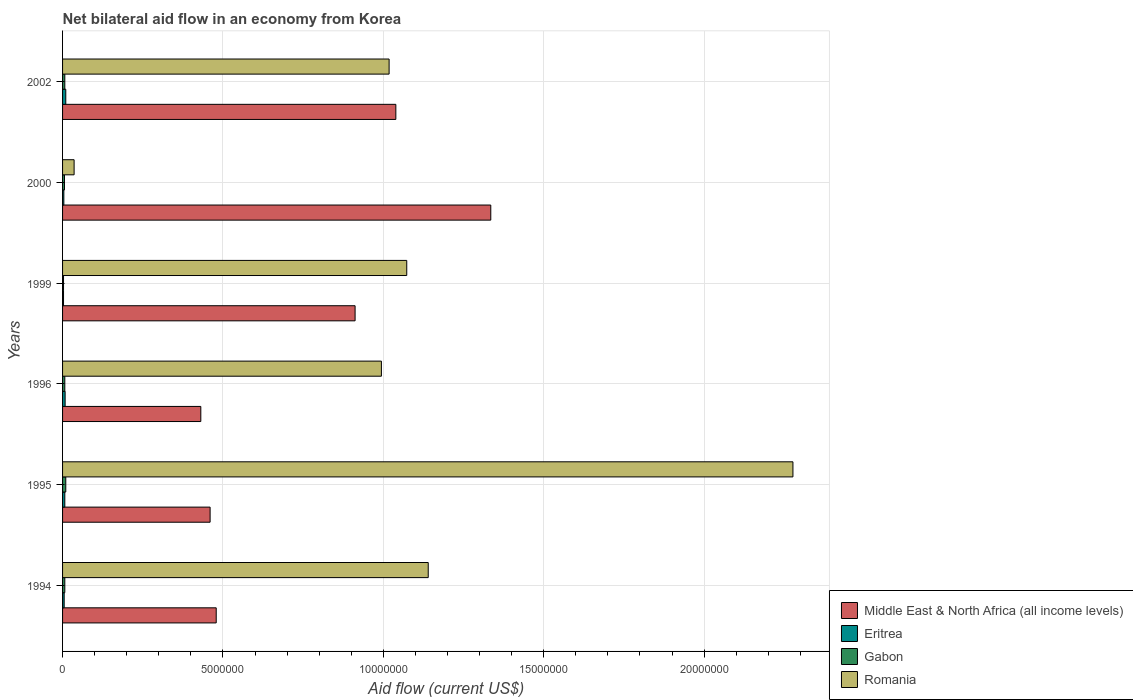Are the number of bars per tick equal to the number of legend labels?
Keep it short and to the point. Yes. Are the number of bars on each tick of the Y-axis equal?
Your answer should be compact. Yes. What is the label of the 4th group of bars from the top?
Your answer should be very brief. 1996. In how many cases, is the number of bars for a given year not equal to the number of legend labels?
Offer a terse response. 0. What is the net bilateral aid flow in Middle East & North Africa (all income levels) in 2000?
Offer a terse response. 1.34e+07. Across all years, what is the maximum net bilateral aid flow in Eritrea?
Give a very brief answer. 1.00e+05. In which year was the net bilateral aid flow in Romania maximum?
Offer a terse response. 1995. What is the total net bilateral aid flow in Eritrea in the graph?
Offer a terse response. 3.70e+05. What is the difference between the net bilateral aid flow in Romania in 1999 and that in 2000?
Ensure brevity in your answer.  1.04e+07. What is the difference between the net bilateral aid flow in Romania in 2000 and the net bilateral aid flow in Middle East & North Africa (all income levels) in 1999?
Keep it short and to the point. -8.76e+06. What is the average net bilateral aid flow in Middle East & North Africa (all income levels) per year?
Make the answer very short. 7.76e+06. In the year 1994, what is the difference between the net bilateral aid flow in Middle East & North Africa (all income levels) and net bilateral aid flow in Gabon?
Make the answer very short. 4.72e+06. What is the ratio of the net bilateral aid flow in Middle East & North Africa (all income levels) in 1994 to that in 1996?
Offer a terse response. 1.11. What is the difference between the highest and the lowest net bilateral aid flow in Gabon?
Keep it short and to the point. 7.00e+04. In how many years, is the net bilateral aid flow in Romania greater than the average net bilateral aid flow in Romania taken over all years?
Make the answer very short. 2. Is it the case that in every year, the sum of the net bilateral aid flow in Romania and net bilateral aid flow in Gabon is greater than the sum of net bilateral aid flow in Middle East & North Africa (all income levels) and net bilateral aid flow in Eritrea?
Provide a succinct answer. Yes. What does the 1st bar from the top in 1999 represents?
Ensure brevity in your answer.  Romania. What does the 3rd bar from the bottom in 1994 represents?
Provide a short and direct response. Gabon. Is it the case that in every year, the sum of the net bilateral aid flow in Eritrea and net bilateral aid flow in Romania is greater than the net bilateral aid flow in Gabon?
Provide a short and direct response. Yes. Are all the bars in the graph horizontal?
Your response must be concise. Yes. How many legend labels are there?
Provide a short and direct response. 4. How are the legend labels stacked?
Make the answer very short. Vertical. What is the title of the graph?
Your answer should be compact. Net bilateral aid flow in an economy from Korea. What is the label or title of the Y-axis?
Give a very brief answer. Years. What is the Aid flow (current US$) in Middle East & North Africa (all income levels) in 1994?
Ensure brevity in your answer.  4.79e+06. What is the Aid flow (current US$) in Eritrea in 1994?
Provide a short and direct response. 5.00e+04. What is the Aid flow (current US$) in Romania in 1994?
Offer a terse response. 1.14e+07. What is the Aid flow (current US$) of Middle East & North Africa (all income levels) in 1995?
Give a very brief answer. 4.60e+06. What is the Aid flow (current US$) in Eritrea in 1995?
Your answer should be very brief. 7.00e+04. What is the Aid flow (current US$) of Romania in 1995?
Your response must be concise. 2.28e+07. What is the Aid flow (current US$) in Middle East & North Africa (all income levels) in 1996?
Give a very brief answer. 4.31e+06. What is the Aid flow (current US$) in Eritrea in 1996?
Provide a succinct answer. 8.00e+04. What is the Aid flow (current US$) in Romania in 1996?
Make the answer very short. 9.94e+06. What is the Aid flow (current US$) of Middle East & North Africa (all income levels) in 1999?
Offer a very short reply. 9.12e+06. What is the Aid flow (current US$) of Eritrea in 1999?
Your answer should be very brief. 3.00e+04. What is the Aid flow (current US$) of Romania in 1999?
Make the answer very short. 1.07e+07. What is the Aid flow (current US$) of Middle East & North Africa (all income levels) in 2000?
Keep it short and to the point. 1.34e+07. What is the Aid flow (current US$) in Romania in 2000?
Make the answer very short. 3.60e+05. What is the Aid flow (current US$) in Middle East & North Africa (all income levels) in 2002?
Your response must be concise. 1.04e+07. What is the Aid flow (current US$) of Romania in 2002?
Your answer should be compact. 1.02e+07. Across all years, what is the maximum Aid flow (current US$) in Middle East & North Africa (all income levels)?
Give a very brief answer. 1.34e+07. Across all years, what is the maximum Aid flow (current US$) of Gabon?
Your answer should be very brief. 1.00e+05. Across all years, what is the maximum Aid flow (current US$) of Romania?
Make the answer very short. 2.28e+07. Across all years, what is the minimum Aid flow (current US$) in Middle East & North Africa (all income levels)?
Ensure brevity in your answer.  4.31e+06. Across all years, what is the minimum Aid flow (current US$) in Gabon?
Your answer should be compact. 3.00e+04. What is the total Aid flow (current US$) of Middle East & North Africa (all income levels) in the graph?
Your answer should be compact. 4.66e+07. What is the total Aid flow (current US$) in Gabon in the graph?
Keep it short and to the point. 4.00e+05. What is the total Aid flow (current US$) of Romania in the graph?
Make the answer very short. 6.54e+07. What is the difference between the Aid flow (current US$) in Eritrea in 1994 and that in 1995?
Your answer should be very brief. -2.00e+04. What is the difference between the Aid flow (current US$) in Romania in 1994 and that in 1995?
Offer a very short reply. -1.14e+07. What is the difference between the Aid flow (current US$) of Eritrea in 1994 and that in 1996?
Ensure brevity in your answer.  -3.00e+04. What is the difference between the Aid flow (current US$) of Romania in 1994 and that in 1996?
Offer a very short reply. 1.46e+06. What is the difference between the Aid flow (current US$) in Middle East & North Africa (all income levels) in 1994 and that in 1999?
Give a very brief answer. -4.33e+06. What is the difference between the Aid flow (current US$) of Eritrea in 1994 and that in 1999?
Offer a very short reply. 2.00e+04. What is the difference between the Aid flow (current US$) in Gabon in 1994 and that in 1999?
Your answer should be compact. 4.00e+04. What is the difference between the Aid flow (current US$) in Romania in 1994 and that in 1999?
Give a very brief answer. 6.70e+05. What is the difference between the Aid flow (current US$) in Middle East & North Africa (all income levels) in 1994 and that in 2000?
Provide a succinct answer. -8.56e+06. What is the difference between the Aid flow (current US$) in Eritrea in 1994 and that in 2000?
Ensure brevity in your answer.  10000. What is the difference between the Aid flow (current US$) in Romania in 1994 and that in 2000?
Give a very brief answer. 1.10e+07. What is the difference between the Aid flow (current US$) in Middle East & North Africa (all income levels) in 1994 and that in 2002?
Provide a succinct answer. -5.60e+06. What is the difference between the Aid flow (current US$) in Eritrea in 1994 and that in 2002?
Ensure brevity in your answer.  -5.00e+04. What is the difference between the Aid flow (current US$) of Romania in 1994 and that in 2002?
Make the answer very short. 1.22e+06. What is the difference between the Aid flow (current US$) in Middle East & North Africa (all income levels) in 1995 and that in 1996?
Provide a succinct answer. 2.90e+05. What is the difference between the Aid flow (current US$) of Gabon in 1995 and that in 1996?
Offer a very short reply. 3.00e+04. What is the difference between the Aid flow (current US$) of Romania in 1995 and that in 1996?
Give a very brief answer. 1.28e+07. What is the difference between the Aid flow (current US$) of Middle East & North Africa (all income levels) in 1995 and that in 1999?
Give a very brief answer. -4.52e+06. What is the difference between the Aid flow (current US$) in Eritrea in 1995 and that in 1999?
Provide a succinct answer. 4.00e+04. What is the difference between the Aid flow (current US$) in Romania in 1995 and that in 1999?
Provide a short and direct response. 1.20e+07. What is the difference between the Aid flow (current US$) of Middle East & North Africa (all income levels) in 1995 and that in 2000?
Your answer should be very brief. -8.75e+06. What is the difference between the Aid flow (current US$) in Eritrea in 1995 and that in 2000?
Provide a succinct answer. 3.00e+04. What is the difference between the Aid flow (current US$) in Romania in 1995 and that in 2000?
Your response must be concise. 2.24e+07. What is the difference between the Aid flow (current US$) of Middle East & North Africa (all income levels) in 1995 and that in 2002?
Provide a succinct answer. -5.79e+06. What is the difference between the Aid flow (current US$) in Eritrea in 1995 and that in 2002?
Provide a short and direct response. -3.00e+04. What is the difference between the Aid flow (current US$) of Romania in 1995 and that in 2002?
Your response must be concise. 1.26e+07. What is the difference between the Aid flow (current US$) in Middle East & North Africa (all income levels) in 1996 and that in 1999?
Your response must be concise. -4.81e+06. What is the difference between the Aid flow (current US$) of Eritrea in 1996 and that in 1999?
Keep it short and to the point. 5.00e+04. What is the difference between the Aid flow (current US$) of Gabon in 1996 and that in 1999?
Make the answer very short. 4.00e+04. What is the difference between the Aid flow (current US$) of Romania in 1996 and that in 1999?
Ensure brevity in your answer.  -7.90e+05. What is the difference between the Aid flow (current US$) in Middle East & North Africa (all income levels) in 1996 and that in 2000?
Provide a short and direct response. -9.04e+06. What is the difference between the Aid flow (current US$) in Eritrea in 1996 and that in 2000?
Ensure brevity in your answer.  4.00e+04. What is the difference between the Aid flow (current US$) in Romania in 1996 and that in 2000?
Make the answer very short. 9.58e+06. What is the difference between the Aid flow (current US$) of Middle East & North Africa (all income levels) in 1996 and that in 2002?
Give a very brief answer. -6.08e+06. What is the difference between the Aid flow (current US$) of Eritrea in 1996 and that in 2002?
Your answer should be compact. -2.00e+04. What is the difference between the Aid flow (current US$) in Middle East & North Africa (all income levels) in 1999 and that in 2000?
Provide a short and direct response. -4.23e+06. What is the difference between the Aid flow (current US$) in Eritrea in 1999 and that in 2000?
Your response must be concise. -10000. What is the difference between the Aid flow (current US$) in Gabon in 1999 and that in 2000?
Offer a terse response. -3.00e+04. What is the difference between the Aid flow (current US$) in Romania in 1999 and that in 2000?
Offer a terse response. 1.04e+07. What is the difference between the Aid flow (current US$) in Middle East & North Africa (all income levels) in 1999 and that in 2002?
Give a very brief answer. -1.27e+06. What is the difference between the Aid flow (current US$) in Gabon in 1999 and that in 2002?
Provide a succinct answer. -4.00e+04. What is the difference between the Aid flow (current US$) in Romania in 1999 and that in 2002?
Your answer should be very brief. 5.50e+05. What is the difference between the Aid flow (current US$) of Middle East & North Africa (all income levels) in 2000 and that in 2002?
Offer a terse response. 2.96e+06. What is the difference between the Aid flow (current US$) in Eritrea in 2000 and that in 2002?
Keep it short and to the point. -6.00e+04. What is the difference between the Aid flow (current US$) in Romania in 2000 and that in 2002?
Keep it short and to the point. -9.82e+06. What is the difference between the Aid flow (current US$) of Middle East & North Africa (all income levels) in 1994 and the Aid flow (current US$) of Eritrea in 1995?
Provide a short and direct response. 4.72e+06. What is the difference between the Aid flow (current US$) in Middle East & North Africa (all income levels) in 1994 and the Aid flow (current US$) in Gabon in 1995?
Your answer should be compact. 4.69e+06. What is the difference between the Aid flow (current US$) of Middle East & North Africa (all income levels) in 1994 and the Aid flow (current US$) of Romania in 1995?
Offer a very short reply. -1.80e+07. What is the difference between the Aid flow (current US$) of Eritrea in 1994 and the Aid flow (current US$) of Gabon in 1995?
Give a very brief answer. -5.00e+04. What is the difference between the Aid flow (current US$) in Eritrea in 1994 and the Aid flow (current US$) in Romania in 1995?
Your response must be concise. -2.27e+07. What is the difference between the Aid flow (current US$) in Gabon in 1994 and the Aid flow (current US$) in Romania in 1995?
Keep it short and to the point. -2.27e+07. What is the difference between the Aid flow (current US$) in Middle East & North Africa (all income levels) in 1994 and the Aid flow (current US$) in Eritrea in 1996?
Give a very brief answer. 4.71e+06. What is the difference between the Aid flow (current US$) in Middle East & North Africa (all income levels) in 1994 and the Aid flow (current US$) in Gabon in 1996?
Provide a short and direct response. 4.72e+06. What is the difference between the Aid flow (current US$) in Middle East & North Africa (all income levels) in 1994 and the Aid flow (current US$) in Romania in 1996?
Ensure brevity in your answer.  -5.15e+06. What is the difference between the Aid flow (current US$) in Eritrea in 1994 and the Aid flow (current US$) in Gabon in 1996?
Your answer should be compact. -2.00e+04. What is the difference between the Aid flow (current US$) in Eritrea in 1994 and the Aid flow (current US$) in Romania in 1996?
Provide a short and direct response. -9.89e+06. What is the difference between the Aid flow (current US$) in Gabon in 1994 and the Aid flow (current US$) in Romania in 1996?
Offer a terse response. -9.87e+06. What is the difference between the Aid flow (current US$) of Middle East & North Africa (all income levels) in 1994 and the Aid flow (current US$) of Eritrea in 1999?
Provide a succinct answer. 4.76e+06. What is the difference between the Aid flow (current US$) in Middle East & North Africa (all income levels) in 1994 and the Aid flow (current US$) in Gabon in 1999?
Offer a very short reply. 4.76e+06. What is the difference between the Aid flow (current US$) of Middle East & North Africa (all income levels) in 1994 and the Aid flow (current US$) of Romania in 1999?
Provide a succinct answer. -5.94e+06. What is the difference between the Aid flow (current US$) in Eritrea in 1994 and the Aid flow (current US$) in Gabon in 1999?
Offer a terse response. 2.00e+04. What is the difference between the Aid flow (current US$) of Eritrea in 1994 and the Aid flow (current US$) of Romania in 1999?
Your response must be concise. -1.07e+07. What is the difference between the Aid flow (current US$) of Gabon in 1994 and the Aid flow (current US$) of Romania in 1999?
Give a very brief answer. -1.07e+07. What is the difference between the Aid flow (current US$) in Middle East & North Africa (all income levels) in 1994 and the Aid flow (current US$) in Eritrea in 2000?
Provide a short and direct response. 4.75e+06. What is the difference between the Aid flow (current US$) in Middle East & North Africa (all income levels) in 1994 and the Aid flow (current US$) in Gabon in 2000?
Offer a terse response. 4.73e+06. What is the difference between the Aid flow (current US$) of Middle East & North Africa (all income levels) in 1994 and the Aid flow (current US$) of Romania in 2000?
Your answer should be compact. 4.43e+06. What is the difference between the Aid flow (current US$) in Eritrea in 1994 and the Aid flow (current US$) in Romania in 2000?
Make the answer very short. -3.10e+05. What is the difference between the Aid flow (current US$) in Gabon in 1994 and the Aid flow (current US$) in Romania in 2000?
Give a very brief answer. -2.90e+05. What is the difference between the Aid flow (current US$) of Middle East & North Africa (all income levels) in 1994 and the Aid flow (current US$) of Eritrea in 2002?
Provide a succinct answer. 4.69e+06. What is the difference between the Aid flow (current US$) in Middle East & North Africa (all income levels) in 1994 and the Aid flow (current US$) in Gabon in 2002?
Make the answer very short. 4.72e+06. What is the difference between the Aid flow (current US$) of Middle East & North Africa (all income levels) in 1994 and the Aid flow (current US$) of Romania in 2002?
Your answer should be compact. -5.39e+06. What is the difference between the Aid flow (current US$) of Eritrea in 1994 and the Aid flow (current US$) of Romania in 2002?
Make the answer very short. -1.01e+07. What is the difference between the Aid flow (current US$) of Gabon in 1994 and the Aid flow (current US$) of Romania in 2002?
Offer a terse response. -1.01e+07. What is the difference between the Aid flow (current US$) in Middle East & North Africa (all income levels) in 1995 and the Aid flow (current US$) in Eritrea in 1996?
Provide a short and direct response. 4.52e+06. What is the difference between the Aid flow (current US$) in Middle East & North Africa (all income levels) in 1995 and the Aid flow (current US$) in Gabon in 1996?
Offer a terse response. 4.53e+06. What is the difference between the Aid flow (current US$) of Middle East & North Africa (all income levels) in 1995 and the Aid flow (current US$) of Romania in 1996?
Offer a terse response. -5.34e+06. What is the difference between the Aid flow (current US$) of Eritrea in 1995 and the Aid flow (current US$) of Romania in 1996?
Provide a short and direct response. -9.87e+06. What is the difference between the Aid flow (current US$) of Gabon in 1995 and the Aid flow (current US$) of Romania in 1996?
Offer a terse response. -9.84e+06. What is the difference between the Aid flow (current US$) in Middle East & North Africa (all income levels) in 1995 and the Aid flow (current US$) in Eritrea in 1999?
Keep it short and to the point. 4.57e+06. What is the difference between the Aid flow (current US$) of Middle East & North Africa (all income levels) in 1995 and the Aid flow (current US$) of Gabon in 1999?
Your answer should be very brief. 4.57e+06. What is the difference between the Aid flow (current US$) of Middle East & North Africa (all income levels) in 1995 and the Aid flow (current US$) of Romania in 1999?
Ensure brevity in your answer.  -6.13e+06. What is the difference between the Aid flow (current US$) of Eritrea in 1995 and the Aid flow (current US$) of Gabon in 1999?
Provide a succinct answer. 4.00e+04. What is the difference between the Aid flow (current US$) of Eritrea in 1995 and the Aid flow (current US$) of Romania in 1999?
Ensure brevity in your answer.  -1.07e+07. What is the difference between the Aid flow (current US$) in Gabon in 1995 and the Aid flow (current US$) in Romania in 1999?
Make the answer very short. -1.06e+07. What is the difference between the Aid flow (current US$) of Middle East & North Africa (all income levels) in 1995 and the Aid flow (current US$) of Eritrea in 2000?
Your answer should be compact. 4.56e+06. What is the difference between the Aid flow (current US$) of Middle East & North Africa (all income levels) in 1995 and the Aid flow (current US$) of Gabon in 2000?
Your response must be concise. 4.54e+06. What is the difference between the Aid flow (current US$) of Middle East & North Africa (all income levels) in 1995 and the Aid flow (current US$) of Romania in 2000?
Ensure brevity in your answer.  4.24e+06. What is the difference between the Aid flow (current US$) in Eritrea in 1995 and the Aid flow (current US$) in Gabon in 2000?
Your answer should be compact. 10000. What is the difference between the Aid flow (current US$) in Middle East & North Africa (all income levels) in 1995 and the Aid flow (current US$) in Eritrea in 2002?
Give a very brief answer. 4.50e+06. What is the difference between the Aid flow (current US$) of Middle East & North Africa (all income levels) in 1995 and the Aid flow (current US$) of Gabon in 2002?
Ensure brevity in your answer.  4.53e+06. What is the difference between the Aid flow (current US$) in Middle East & North Africa (all income levels) in 1995 and the Aid flow (current US$) in Romania in 2002?
Provide a succinct answer. -5.58e+06. What is the difference between the Aid flow (current US$) in Eritrea in 1995 and the Aid flow (current US$) in Romania in 2002?
Offer a terse response. -1.01e+07. What is the difference between the Aid flow (current US$) in Gabon in 1995 and the Aid flow (current US$) in Romania in 2002?
Your answer should be very brief. -1.01e+07. What is the difference between the Aid flow (current US$) of Middle East & North Africa (all income levels) in 1996 and the Aid flow (current US$) of Eritrea in 1999?
Offer a very short reply. 4.28e+06. What is the difference between the Aid flow (current US$) of Middle East & North Africa (all income levels) in 1996 and the Aid flow (current US$) of Gabon in 1999?
Offer a terse response. 4.28e+06. What is the difference between the Aid flow (current US$) in Middle East & North Africa (all income levels) in 1996 and the Aid flow (current US$) in Romania in 1999?
Your response must be concise. -6.42e+06. What is the difference between the Aid flow (current US$) of Eritrea in 1996 and the Aid flow (current US$) of Gabon in 1999?
Provide a short and direct response. 5.00e+04. What is the difference between the Aid flow (current US$) in Eritrea in 1996 and the Aid flow (current US$) in Romania in 1999?
Your answer should be compact. -1.06e+07. What is the difference between the Aid flow (current US$) of Gabon in 1996 and the Aid flow (current US$) of Romania in 1999?
Provide a short and direct response. -1.07e+07. What is the difference between the Aid flow (current US$) of Middle East & North Africa (all income levels) in 1996 and the Aid flow (current US$) of Eritrea in 2000?
Make the answer very short. 4.27e+06. What is the difference between the Aid flow (current US$) in Middle East & North Africa (all income levels) in 1996 and the Aid flow (current US$) in Gabon in 2000?
Give a very brief answer. 4.25e+06. What is the difference between the Aid flow (current US$) in Middle East & North Africa (all income levels) in 1996 and the Aid flow (current US$) in Romania in 2000?
Make the answer very short. 3.95e+06. What is the difference between the Aid flow (current US$) in Eritrea in 1996 and the Aid flow (current US$) in Romania in 2000?
Provide a short and direct response. -2.80e+05. What is the difference between the Aid flow (current US$) in Middle East & North Africa (all income levels) in 1996 and the Aid flow (current US$) in Eritrea in 2002?
Make the answer very short. 4.21e+06. What is the difference between the Aid flow (current US$) in Middle East & North Africa (all income levels) in 1996 and the Aid flow (current US$) in Gabon in 2002?
Give a very brief answer. 4.24e+06. What is the difference between the Aid flow (current US$) in Middle East & North Africa (all income levels) in 1996 and the Aid flow (current US$) in Romania in 2002?
Give a very brief answer. -5.87e+06. What is the difference between the Aid flow (current US$) of Eritrea in 1996 and the Aid flow (current US$) of Romania in 2002?
Offer a very short reply. -1.01e+07. What is the difference between the Aid flow (current US$) in Gabon in 1996 and the Aid flow (current US$) in Romania in 2002?
Keep it short and to the point. -1.01e+07. What is the difference between the Aid flow (current US$) in Middle East & North Africa (all income levels) in 1999 and the Aid flow (current US$) in Eritrea in 2000?
Your answer should be compact. 9.08e+06. What is the difference between the Aid flow (current US$) in Middle East & North Africa (all income levels) in 1999 and the Aid flow (current US$) in Gabon in 2000?
Keep it short and to the point. 9.06e+06. What is the difference between the Aid flow (current US$) in Middle East & North Africa (all income levels) in 1999 and the Aid flow (current US$) in Romania in 2000?
Provide a succinct answer. 8.76e+06. What is the difference between the Aid flow (current US$) in Eritrea in 1999 and the Aid flow (current US$) in Romania in 2000?
Ensure brevity in your answer.  -3.30e+05. What is the difference between the Aid flow (current US$) in Gabon in 1999 and the Aid flow (current US$) in Romania in 2000?
Offer a terse response. -3.30e+05. What is the difference between the Aid flow (current US$) of Middle East & North Africa (all income levels) in 1999 and the Aid flow (current US$) of Eritrea in 2002?
Offer a terse response. 9.02e+06. What is the difference between the Aid flow (current US$) in Middle East & North Africa (all income levels) in 1999 and the Aid flow (current US$) in Gabon in 2002?
Offer a very short reply. 9.05e+06. What is the difference between the Aid flow (current US$) of Middle East & North Africa (all income levels) in 1999 and the Aid flow (current US$) of Romania in 2002?
Make the answer very short. -1.06e+06. What is the difference between the Aid flow (current US$) of Eritrea in 1999 and the Aid flow (current US$) of Gabon in 2002?
Give a very brief answer. -4.00e+04. What is the difference between the Aid flow (current US$) of Eritrea in 1999 and the Aid flow (current US$) of Romania in 2002?
Provide a short and direct response. -1.02e+07. What is the difference between the Aid flow (current US$) of Gabon in 1999 and the Aid flow (current US$) of Romania in 2002?
Offer a terse response. -1.02e+07. What is the difference between the Aid flow (current US$) of Middle East & North Africa (all income levels) in 2000 and the Aid flow (current US$) of Eritrea in 2002?
Your response must be concise. 1.32e+07. What is the difference between the Aid flow (current US$) in Middle East & North Africa (all income levels) in 2000 and the Aid flow (current US$) in Gabon in 2002?
Make the answer very short. 1.33e+07. What is the difference between the Aid flow (current US$) of Middle East & North Africa (all income levels) in 2000 and the Aid flow (current US$) of Romania in 2002?
Make the answer very short. 3.17e+06. What is the difference between the Aid flow (current US$) in Eritrea in 2000 and the Aid flow (current US$) in Romania in 2002?
Keep it short and to the point. -1.01e+07. What is the difference between the Aid flow (current US$) of Gabon in 2000 and the Aid flow (current US$) of Romania in 2002?
Your response must be concise. -1.01e+07. What is the average Aid flow (current US$) of Middle East & North Africa (all income levels) per year?
Ensure brevity in your answer.  7.76e+06. What is the average Aid flow (current US$) of Eritrea per year?
Offer a terse response. 6.17e+04. What is the average Aid flow (current US$) in Gabon per year?
Your answer should be compact. 6.67e+04. What is the average Aid flow (current US$) of Romania per year?
Provide a succinct answer. 1.09e+07. In the year 1994, what is the difference between the Aid flow (current US$) in Middle East & North Africa (all income levels) and Aid flow (current US$) in Eritrea?
Keep it short and to the point. 4.74e+06. In the year 1994, what is the difference between the Aid flow (current US$) of Middle East & North Africa (all income levels) and Aid flow (current US$) of Gabon?
Your response must be concise. 4.72e+06. In the year 1994, what is the difference between the Aid flow (current US$) in Middle East & North Africa (all income levels) and Aid flow (current US$) in Romania?
Offer a very short reply. -6.61e+06. In the year 1994, what is the difference between the Aid flow (current US$) in Eritrea and Aid flow (current US$) in Gabon?
Give a very brief answer. -2.00e+04. In the year 1994, what is the difference between the Aid flow (current US$) of Eritrea and Aid flow (current US$) of Romania?
Offer a very short reply. -1.14e+07. In the year 1994, what is the difference between the Aid flow (current US$) in Gabon and Aid flow (current US$) in Romania?
Make the answer very short. -1.13e+07. In the year 1995, what is the difference between the Aid flow (current US$) in Middle East & North Africa (all income levels) and Aid flow (current US$) in Eritrea?
Give a very brief answer. 4.53e+06. In the year 1995, what is the difference between the Aid flow (current US$) of Middle East & North Africa (all income levels) and Aid flow (current US$) of Gabon?
Provide a short and direct response. 4.50e+06. In the year 1995, what is the difference between the Aid flow (current US$) of Middle East & North Africa (all income levels) and Aid flow (current US$) of Romania?
Give a very brief answer. -1.82e+07. In the year 1995, what is the difference between the Aid flow (current US$) of Eritrea and Aid flow (current US$) of Gabon?
Keep it short and to the point. -3.00e+04. In the year 1995, what is the difference between the Aid flow (current US$) in Eritrea and Aid flow (current US$) in Romania?
Give a very brief answer. -2.27e+07. In the year 1995, what is the difference between the Aid flow (current US$) in Gabon and Aid flow (current US$) in Romania?
Provide a short and direct response. -2.27e+07. In the year 1996, what is the difference between the Aid flow (current US$) in Middle East & North Africa (all income levels) and Aid flow (current US$) in Eritrea?
Offer a terse response. 4.23e+06. In the year 1996, what is the difference between the Aid flow (current US$) of Middle East & North Africa (all income levels) and Aid flow (current US$) of Gabon?
Provide a short and direct response. 4.24e+06. In the year 1996, what is the difference between the Aid flow (current US$) in Middle East & North Africa (all income levels) and Aid flow (current US$) in Romania?
Provide a short and direct response. -5.63e+06. In the year 1996, what is the difference between the Aid flow (current US$) in Eritrea and Aid flow (current US$) in Gabon?
Make the answer very short. 10000. In the year 1996, what is the difference between the Aid flow (current US$) in Eritrea and Aid flow (current US$) in Romania?
Offer a terse response. -9.86e+06. In the year 1996, what is the difference between the Aid flow (current US$) in Gabon and Aid flow (current US$) in Romania?
Make the answer very short. -9.87e+06. In the year 1999, what is the difference between the Aid flow (current US$) in Middle East & North Africa (all income levels) and Aid flow (current US$) in Eritrea?
Your response must be concise. 9.09e+06. In the year 1999, what is the difference between the Aid flow (current US$) in Middle East & North Africa (all income levels) and Aid flow (current US$) in Gabon?
Provide a succinct answer. 9.09e+06. In the year 1999, what is the difference between the Aid flow (current US$) in Middle East & North Africa (all income levels) and Aid flow (current US$) in Romania?
Your answer should be compact. -1.61e+06. In the year 1999, what is the difference between the Aid flow (current US$) in Eritrea and Aid flow (current US$) in Gabon?
Provide a succinct answer. 0. In the year 1999, what is the difference between the Aid flow (current US$) in Eritrea and Aid flow (current US$) in Romania?
Offer a very short reply. -1.07e+07. In the year 1999, what is the difference between the Aid flow (current US$) in Gabon and Aid flow (current US$) in Romania?
Offer a very short reply. -1.07e+07. In the year 2000, what is the difference between the Aid flow (current US$) of Middle East & North Africa (all income levels) and Aid flow (current US$) of Eritrea?
Provide a short and direct response. 1.33e+07. In the year 2000, what is the difference between the Aid flow (current US$) of Middle East & North Africa (all income levels) and Aid flow (current US$) of Gabon?
Your response must be concise. 1.33e+07. In the year 2000, what is the difference between the Aid flow (current US$) of Middle East & North Africa (all income levels) and Aid flow (current US$) of Romania?
Give a very brief answer. 1.30e+07. In the year 2000, what is the difference between the Aid flow (current US$) in Eritrea and Aid flow (current US$) in Romania?
Offer a terse response. -3.20e+05. In the year 2002, what is the difference between the Aid flow (current US$) in Middle East & North Africa (all income levels) and Aid flow (current US$) in Eritrea?
Offer a terse response. 1.03e+07. In the year 2002, what is the difference between the Aid flow (current US$) of Middle East & North Africa (all income levels) and Aid flow (current US$) of Gabon?
Keep it short and to the point. 1.03e+07. In the year 2002, what is the difference between the Aid flow (current US$) in Middle East & North Africa (all income levels) and Aid flow (current US$) in Romania?
Ensure brevity in your answer.  2.10e+05. In the year 2002, what is the difference between the Aid flow (current US$) of Eritrea and Aid flow (current US$) of Gabon?
Keep it short and to the point. 3.00e+04. In the year 2002, what is the difference between the Aid flow (current US$) of Eritrea and Aid flow (current US$) of Romania?
Offer a terse response. -1.01e+07. In the year 2002, what is the difference between the Aid flow (current US$) of Gabon and Aid flow (current US$) of Romania?
Your answer should be very brief. -1.01e+07. What is the ratio of the Aid flow (current US$) in Middle East & North Africa (all income levels) in 1994 to that in 1995?
Provide a succinct answer. 1.04. What is the ratio of the Aid flow (current US$) in Gabon in 1994 to that in 1995?
Provide a short and direct response. 0.7. What is the ratio of the Aid flow (current US$) in Romania in 1994 to that in 1995?
Keep it short and to the point. 0.5. What is the ratio of the Aid flow (current US$) of Middle East & North Africa (all income levels) in 1994 to that in 1996?
Your response must be concise. 1.11. What is the ratio of the Aid flow (current US$) in Eritrea in 1994 to that in 1996?
Your response must be concise. 0.62. What is the ratio of the Aid flow (current US$) of Romania in 1994 to that in 1996?
Your answer should be very brief. 1.15. What is the ratio of the Aid flow (current US$) in Middle East & North Africa (all income levels) in 1994 to that in 1999?
Offer a terse response. 0.53. What is the ratio of the Aid flow (current US$) in Gabon in 1994 to that in 1999?
Give a very brief answer. 2.33. What is the ratio of the Aid flow (current US$) in Romania in 1994 to that in 1999?
Provide a succinct answer. 1.06. What is the ratio of the Aid flow (current US$) of Middle East & North Africa (all income levels) in 1994 to that in 2000?
Provide a succinct answer. 0.36. What is the ratio of the Aid flow (current US$) of Eritrea in 1994 to that in 2000?
Offer a very short reply. 1.25. What is the ratio of the Aid flow (current US$) of Gabon in 1994 to that in 2000?
Offer a very short reply. 1.17. What is the ratio of the Aid flow (current US$) in Romania in 1994 to that in 2000?
Give a very brief answer. 31.67. What is the ratio of the Aid flow (current US$) of Middle East & North Africa (all income levels) in 1994 to that in 2002?
Your response must be concise. 0.46. What is the ratio of the Aid flow (current US$) of Romania in 1994 to that in 2002?
Your response must be concise. 1.12. What is the ratio of the Aid flow (current US$) of Middle East & North Africa (all income levels) in 1995 to that in 1996?
Offer a terse response. 1.07. What is the ratio of the Aid flow (current US$) of Eritrea in 1995 to that in 1996?
Your answer should be compact. 0.88. What is the ratio of the Aid flow (current US$) of Gabon in 1995 to that in 1996?
Ensure brevity in your answer.  1.43. What is the ratio of the Aid flow (current US$) of Romania in 1995 to that in 1996?
Your answer should be compact. 2.29. What is the ratio of the Aid flow (current US$) of Middle East & North Africa (all income levels) in 1995 to that in 1999?
Give a very brief answer. 0.5. What is the ratio of the Aid flow (current US$) in Eritrea in 1995 to that in 1999?
Offer a terse response. 2.33. What is the ratio of the Aid flow (current US$) of Gabon in 1995 to that in 1999?
Make the answer very short. 3.33. What is the ratio of the Aid flow (current US$) in Romania in 1995 to that in 1999?
Offer a terse response. 2.12. What is the ratio of the Aid flow (current US$) of Middle East & North Africa (all income levels) in 1995 to that in 2000?
Make the answer very short. 0.34. What is the ratio of the Aid flow (current US$) of Eritrea in 1995 to that in 2000?
Give a very brief answer. 1.75. What is the ratio of the Aid flow (current US$) of Romania in 1995 to that in 2000?
Give a very brief answer. 63.25. What is the ratio of the Aid flow (current US$) of Middle East & North Africa (all income levels) in 1995 to that in 2002?
Offer a terse response. 0.44. What is the ratio of the Aid flow (current US$) in Eritrea in 1995 to that in 2002?
Keep it short and to the point. 0.7. What is the ratio of the Aid flow (current US$) in Gabon in 1995 to that in 2002?
Give a very brief answer. 1.43. What is the ratio of the Aid flow (current US$) in Romania in 1995 to that in 2002?
Provide a short and direct response. 2.24. What is the ratio of the Aid flow (current US$) of Middle East & North Africa (all income levels) in 1996 to that in 1999?
Make the answer very short. 0.47. What is the ratio of the Aid flow (current US$) in Eritrea in 1996 to that in 1999?
Provide a succinct answer. 2.67. What is the ratio of the Aid flow (current US$) in Gabon in 1996 to that in 1999?
Ensure brevity in your answer.  2.33. What is the ratio of the Aid flow (current US$) in Romania in 1996 to that in 1999?
Provide a succinct answer. 0.93. What is the ratio of the Aid flow (current US$) of Middle East & North Africa (all income levels) in 1996 to that in 2000?
Your answer should be very brief. 0.32. What is the ratio of the Aid flow (current US$) of Eritrea in 1996 to that in 2000?
Your answer should be very brief. 2. What is the ratio of the Aid flow (current US$) of Gabon in 1996 to that in 2000?
Provide a short and direct response. 1.17. What is the ratio of the Aid flow (current US$) of Romania in 1996 to that in 2000?
Your answer should be compact. 27.61. What is the ratio of the Aid flow (current US$) of Middle East & North Africa (all income levels) in 1996 to that in 2002?
Make the answer very short. 0.41. What is the ratio of the Aid flow (current US$) in Gabon in 1996 to that in 2002?
Provide a succinct answer. 1. What is the ratio of the Aid flow (current US$) of Romania in 1996 to that in 2002?
Provide a succinct answer. 0.98. What is the ratio of the Aid flow (current US$) in Middle East & North Africa (all income levels) in 1999 to that in 2000?
Ensure brevity in your answer.  0.68. What is the ratio of the Aid flow (current US$) in Eritrea in 1999 to that in 2000?
Ensure brevity in your answer.  0.75. What is the ratio of the Aid flow (current US$) of Romania in 1999 to that in 2000?
Your response must be concise. 29.81. What is the ratio of the Aid flow (current US$) of Middle East & North Africa (all income levels) in 1999 to that in 2002?
Keep it short and to the point. 0.88. What is the ratio of the Aid flow (current US$) of Eritrea in 1999 to that in 2002?
Ensure brevity in your answer.  0.3. What is the ratio of the Aid flow (current US$) in Gabon in 1999 to that in 2002?
Provide a succinct answer. 0.43. What is the ratio of the Aid flow (current US$) of Romania in 1999 to that in 2002?
Ensure brevity in your answer.  1.05. What is the ratio of the Aid flow (current US$) in Middle East & North Africa (all income levels) in 2000 to that in 2002?
Provide a succinct answer. 1.28. What is the ratio of the Aid flow (current US$) in Romania in 2000 to that in 2002?
Offer a very short reply. 0.04. What is the difference between the highest and the second highest Aid flow (current US$) of Middle East & North Africa (all income levels)?
Provide a short and direct response. 2.96e+06. What is the difference between the highest and the second highest Aid flow (current US$) of Gabon?
Your answer should be compact. 3.00e+04. What is the difference between the highest and the second highest Aid flow (current US$) of Romania?
Your answer should be very brief. 1.14e+07. What is the difference between the highest and the lowest Aid flow (current US$) of Middle East & North Africa (all income levels)?
Your answer should be compact. 9.04e+06. What is the difference between the highest and the lowest Aid flow (current US$) of Eritrea?
Keep it short and to the point. 7.00e+04. What is the difference between the highest and the lowest Aid flow (current US$) in Gabon?
Offer a terse response. 7.00e+04. What is the difference between the highest and the lowest Aid flow (current US$) in Romania?
Give a very brief answer. 2.24e+07. 